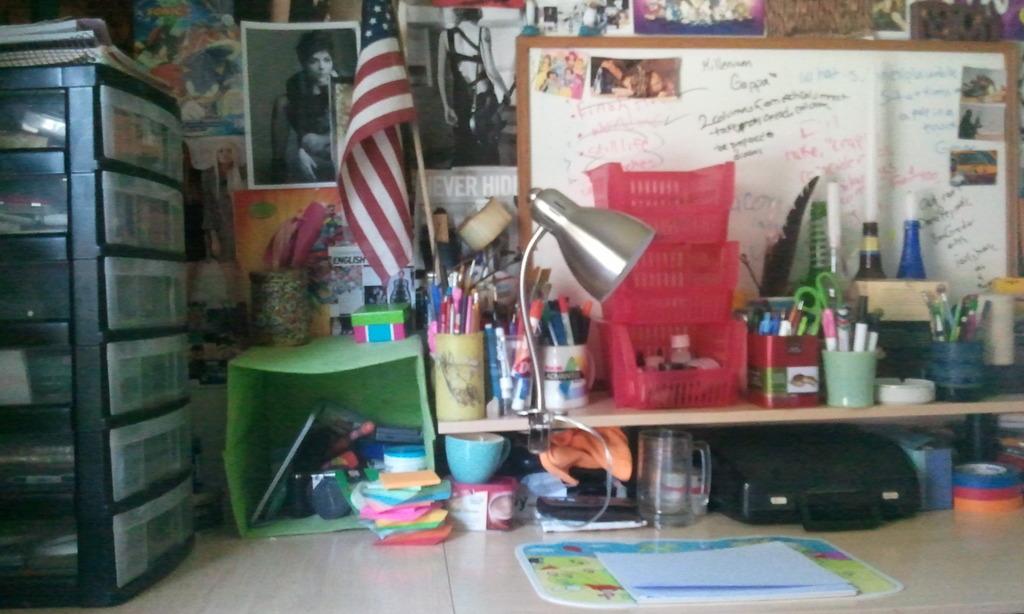Can anything on the whiteboard be read?
Make the answer very short. Yes. 